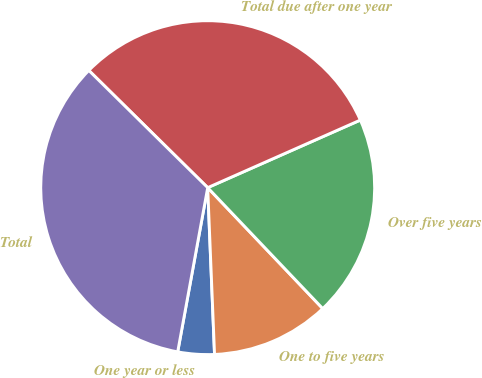Convert chart. <chart><loc_0><loc_0><loc_500><loc_500><pie_chart><fcel>One year or less<fcel>One to five years<fcel>Over five years<fcel>Total due after one year<fcel>Total<nl><fcel>3.53%<fcel>11.45%<fcel>19.53%<fcel>30.98%<fcel>34.51%<nl></chart> 